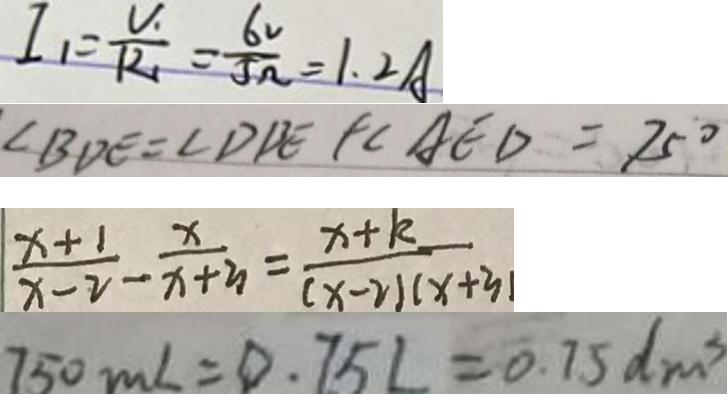<formula> <loc_0><loc_0><loc_500><loc_500>I _ { 1 } = \frac { U _ { 1 } } { R _ { 1 } } = \frac { 6 V } { 5 \Omega } = 1 . 2 A 
 \angle B D E = \angle D B E + \angle A E D = 7 5 ^ { \circ } 
 \frac { x + 1 } { x - 2 } - \frac { x } { x + 3 } = \frac { x + k } { ( x - 2 ) ( x + 3 ) } 
 7 5 0 m L = 0 . 7 5 L = 0 . 7 5 d m ^ { 3 }</formula> 